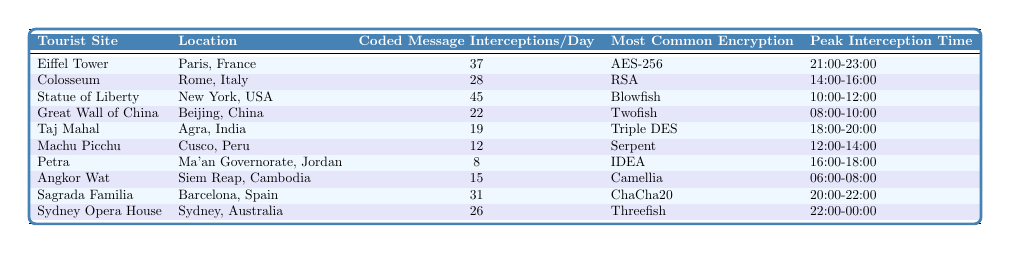What is the most common encryption method used at the Statue of Liberty? The table indicates that the most common encryption method used at the Statue of Liberty is "Blowfish."
Answer: Blowfish How many coded message interceptions per day are recorded at the Eiffel Tower? According to the table, the number of coded message interceptions per day at the Eiffel Tower is 37.
Answer: 37 Which tourist site has the peak interception time between 12:00 and 14:00? Looking at the table, Machu Picchu has its peak interception time listed as 12:00-14:00.
Answer: Machu Picchu What is the average number of coded message interceptions per day for the Taj Mahal and Petra? The coded message interceptions for the Taj Mahal is 19 and for Petra is 8. Adding both gives 19 + 8 = 27, and dividing by 2 gives an average of 27 / 2 = 13.5.
Answer: 13.5 Is the Sagrada Familia's peak interception time later than that of the Colosseum? The Sagrada Familia's peak interception time is 20:00-22:00, while the Colosseum's peak time is 14:00-16:00. Since 20:00 is later than 14:00, the statement is true.
Answer: Yes What is the total number of coded message interceptions per day for the Great Wall of China and the Angkor Wat combined? The Great Wall of China has 22 interceptions per day and Angkor Wat has 15. Adding these gives 22 + 15 = 37.
Answer: 37 How many more coded message interceptions per day does the Statue of Liberty have compared to the Great Wall of China? The Statue of Liberty has 45 interceptions per day, while the Great Wall of China has 22. The difference is calculated as 45 - 22 = 23.
Answer: 23 Which location has the highest coded message interceptions and what is that number? The table shows the Statue of Liberty has the highest number of coded message interceptions at 45.
Answer: 45 If you were to visit the Eiffel Tower at its peak interception time, what time would it be? The peak interception time for the Eiffel Tower is listed as 21:00-23:00. Thus, visiting during this timeframe would align with the peak.
Answer: 21:00-23:00 Does Machu Picchu record more coded message interceptions per day than the Taj Mahal? Machu Picchu records 12 interceptions, while the Taj Mahal records 19. Since 12 is less than 19, the statement is false.
Answer: No 